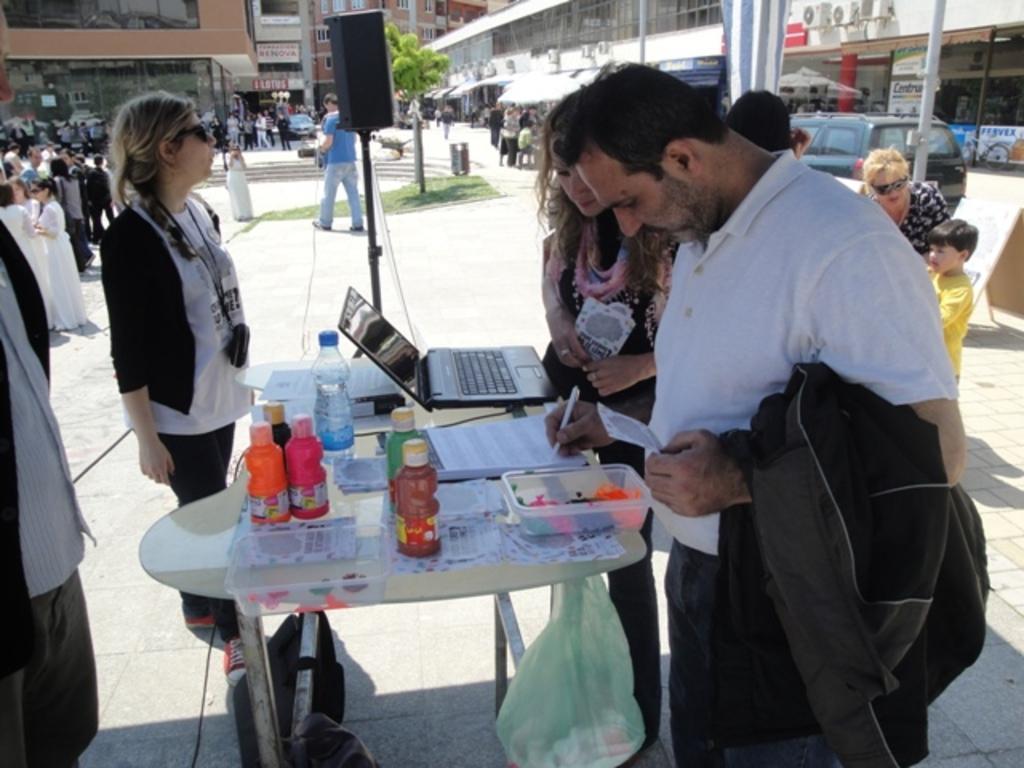Please provide a concise description of this image. In this image there are group of people and at the middle of the image there is a table on which there are bottles and laptop and at the right side of the image there is a person wearing white color T-shirt writing and also holding black color jacket in his hand and at the background there are buildings 